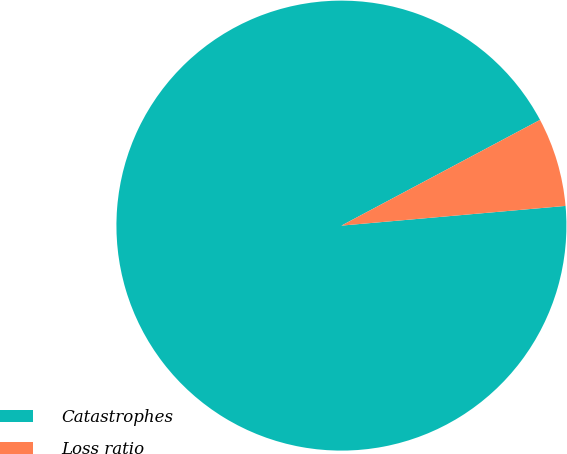Convert chart. <chart><loc_0><loc_0><loc_500><loc_500><pie_chart><fcel>Catastrophes<fcel>Loss ratio<nl><fcel>93.61%<fcel>6.39%<nl></chart> 